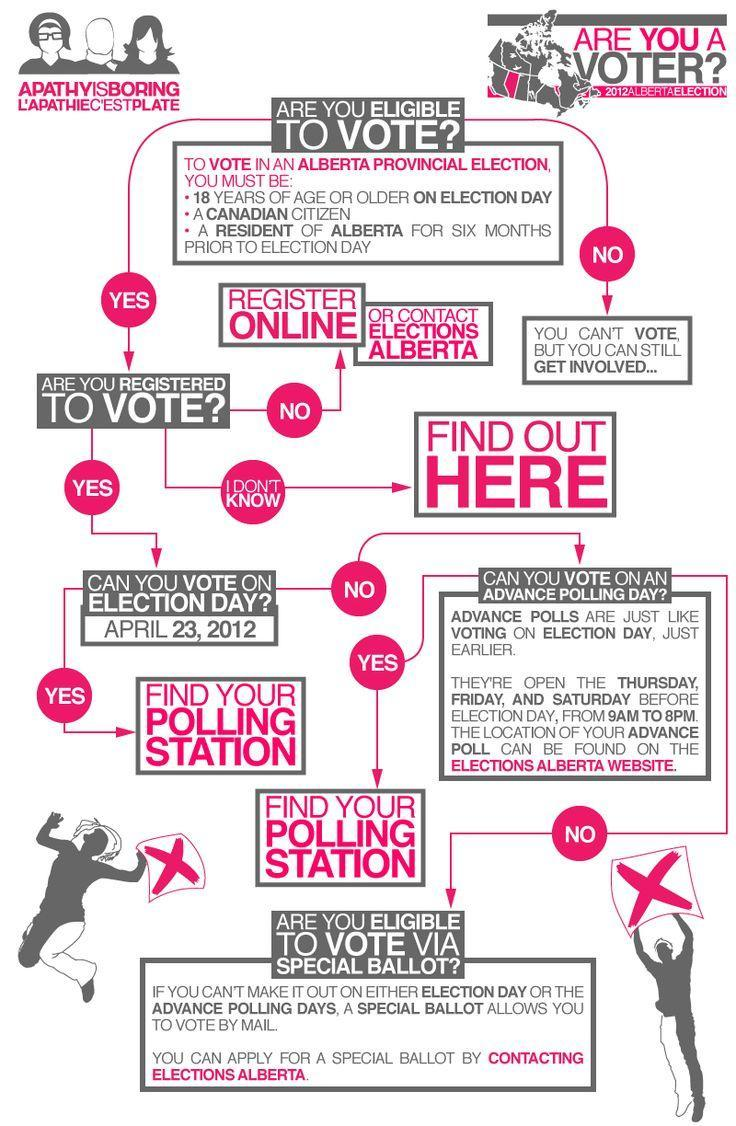What step should be taken if a person is not a registered voter?
Answer the question with a short phrase. REGISTER ONLINE, Register Online 